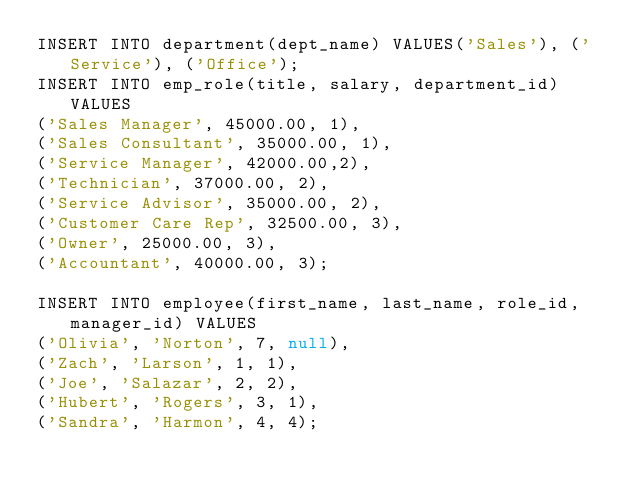<code> <loc_0><loc_0><loc_500><loc_500><_SQL_>INSERT INTO department(dept_name) VALUES('Sales'), ('Service'), ('Office');
INSERT INTO emp_role(title, salary, department_id) VALUES
('Sales Manager', 45000.00, 1),
('Sales Consultant', 35000.00, 1),
('Service Manager', 42000.00,2),
('Technician', 37000.00, 2),
('Service Advisor', 35000.00, 2),
('Customer Care Rep', 32500.00, 3),
('Owner', 25000.00, 3),
('Accountant', 40000.00, 3);

INSERT INTO employee(first_name, last_name, role_id, manager_id) VALUES
('Olivia', 'Norton', 7, null),
('Zach', 'Larson', 1, 1),
('Joe', 'Salazar', 2, 2),
('Hubert', 'Rogers', 3, 1),
('Sandra', 'Harmon', 4, 4);</code> 